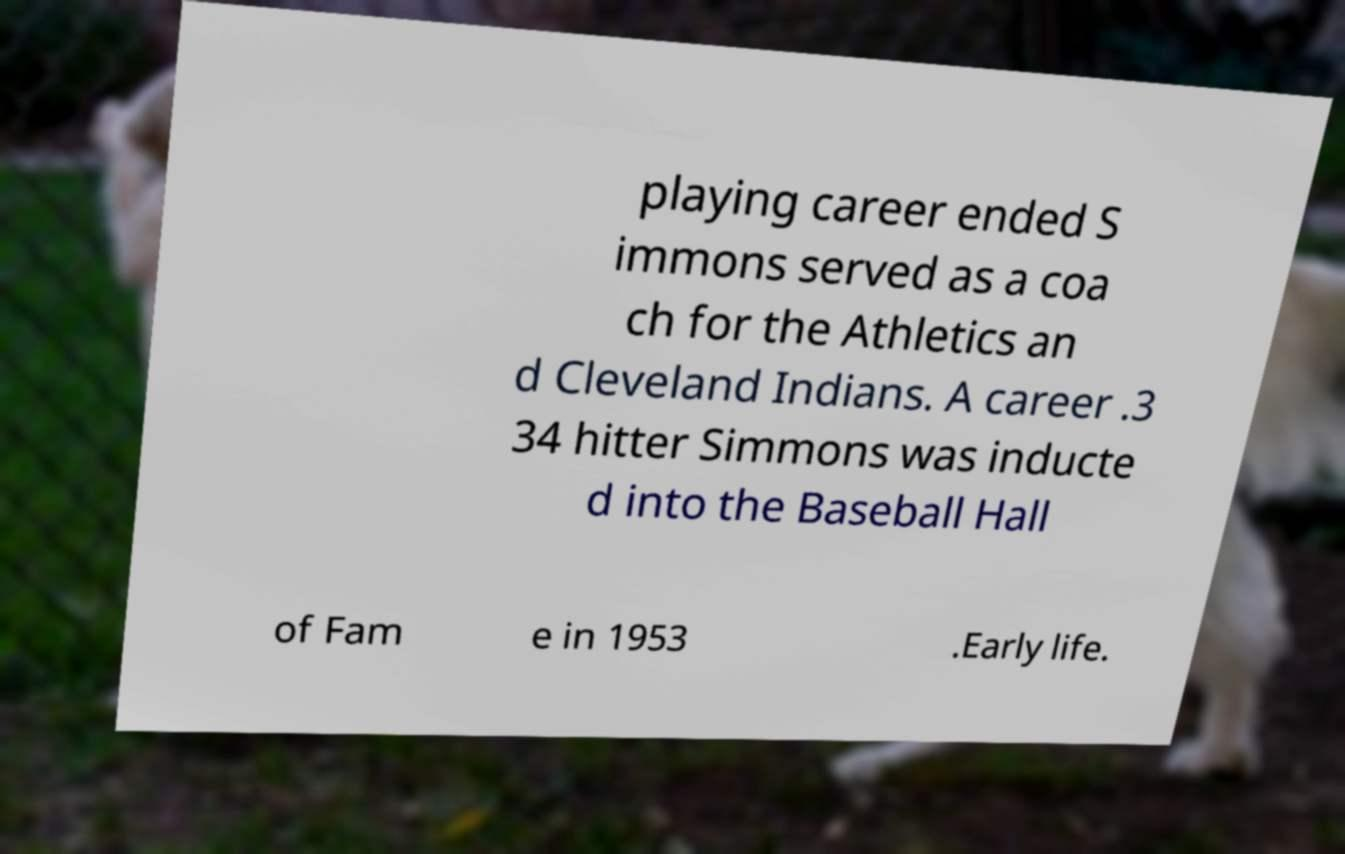There's text embedded in this image that I need extracted. Can you transcribe it verbatim? playing career ended S immons served as a coa ch for the Athletics an d Cleveland Indians. A career .3 34 hitter Simmons was inducte d into the Baseball Hall of Fam e in 1953 .Early life. 